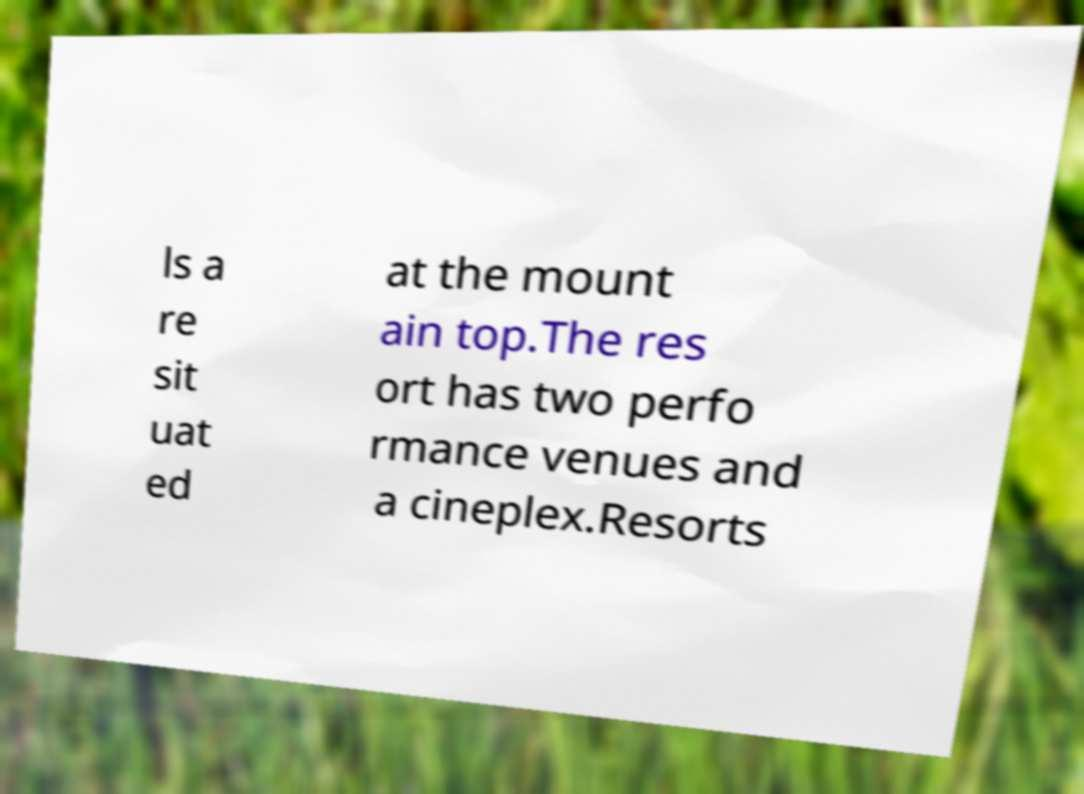There's text embedded in this image that I need extracted. Can you transcribe it verbatim? ls a re sit uat ed at the mount ain top.The res ort has two perfo rmance venues and a cineplex.Resorts 